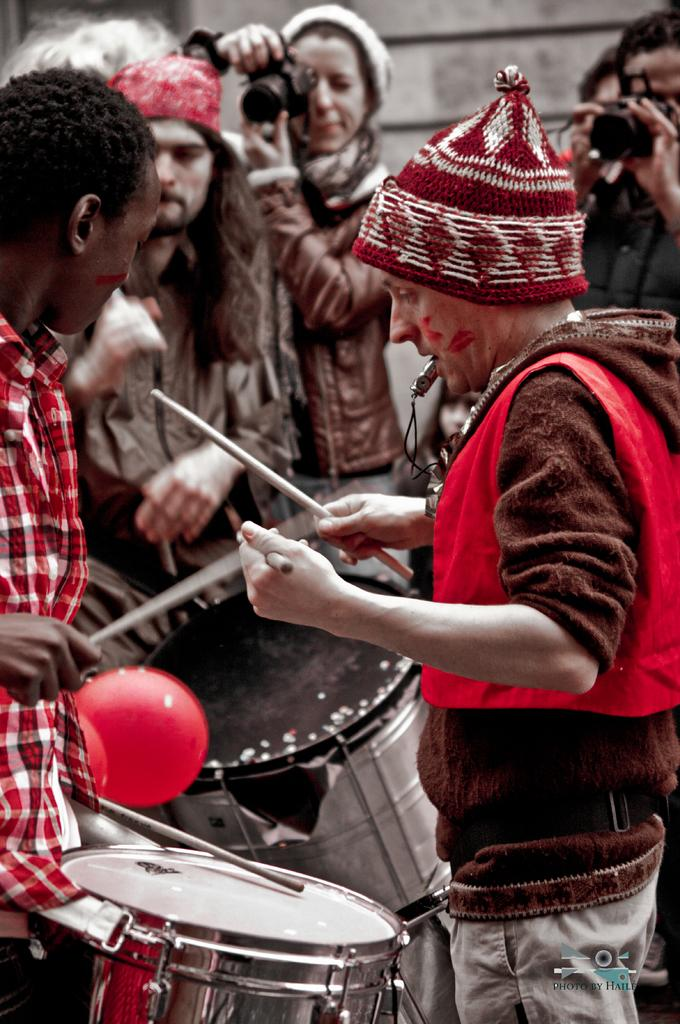What activity are the people in the foreground engaged in? The people in the foreground are playing drums. What are the people in the background doing? The people in the background are clicking photos with their cameras. What type of plants are being sorted by the lead drummer in the image? There are no plants or sorting activity present in the image. 